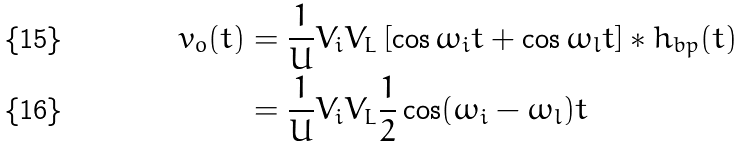<formula> <loc_0><loc_0><loc_500><loc_500>v _ { o } ( t ) & = \frac { 1 } { U } V _ { i } V _ { L } \left [ \cos \omega _ { i } t + \cos \omega _ { l } t \right ] * h _ { b p } ( t ) \\ & = \frac { 1 } { U } V _ { i } V _ { L } \frac { 1 } { 2 } \cos ( \omega _ { i } - \omega _ { l } ) t</formula> 